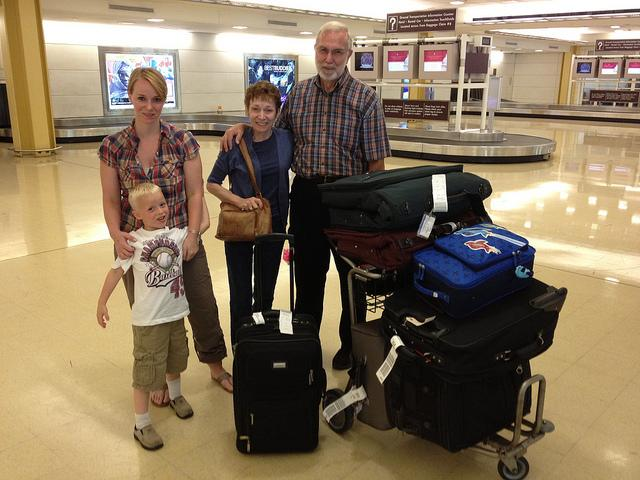What is this area for? baggage claim 